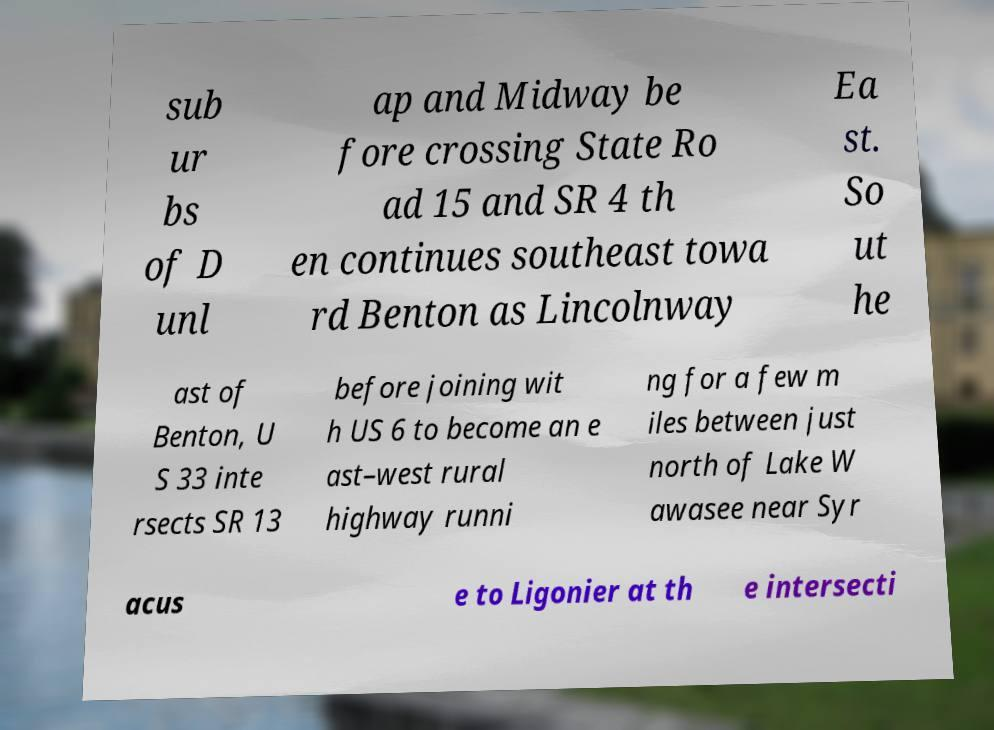Can you read and provide the text displayed in the image?This photo seems to have some interesting text. Can you extract and type it out for me? sub ur bs of D unl ap and Midway be fore crossing State Ro ad 15 and SR 4 th en continues southeast towa rd Benton as Lincolnway Ea st. So ut he ast of Benton, U S 33 inte rsects SR 13 before joining wit h US 6 to become an e ast–west rural highway runni ng for a few m iles between just north of Lake W awasee near Syr acus e to Ligonier at th e intersecti 